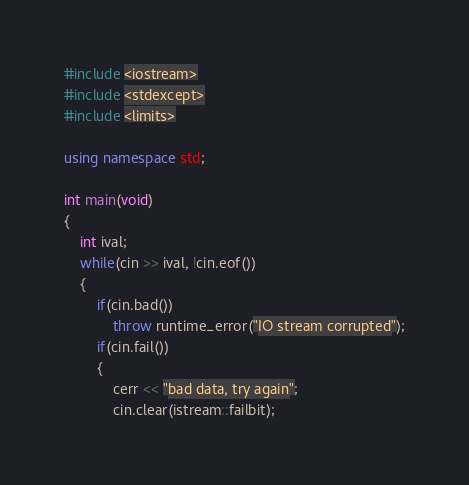<code> <loc_0><loc_0><loc_500><loc_500><_C++_>#include <iostream>
#include <stdexcept>
#include <limits>

using namespace std;

int main(void)
{
	int ival;
	while(cin >> ival, !cin.eof())
	{
		if(cin.bad())
			throw runtime_error("IO stream corrupted");
		if(cin.fail())
		{
			cerr << "bad data, try again";
			cin.clear(istream::failbit);</code> 